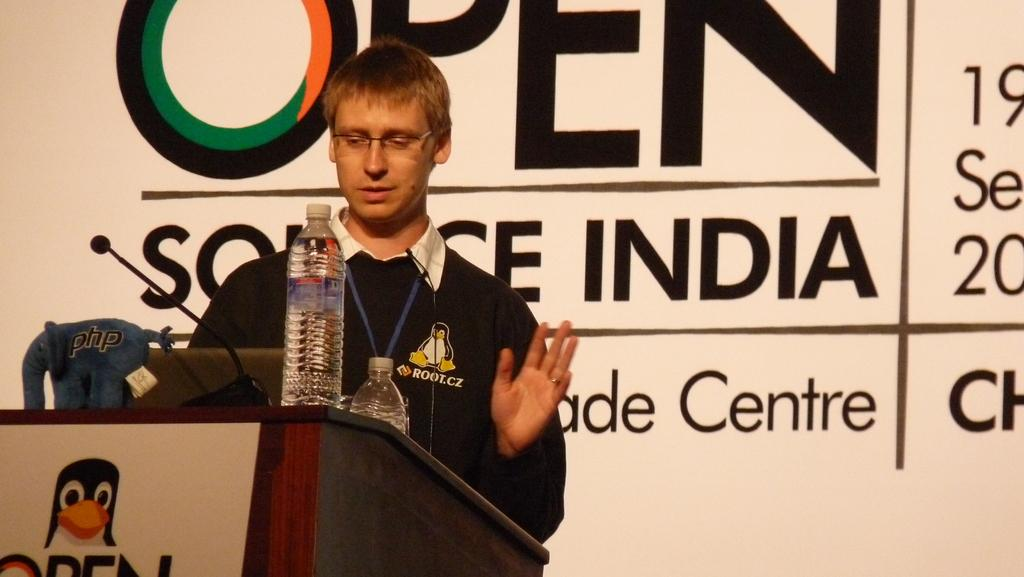<image>
Give a short and clear explanation of the subsequent image. Man giving a presentation in front of a wall which say OPEN on it. 